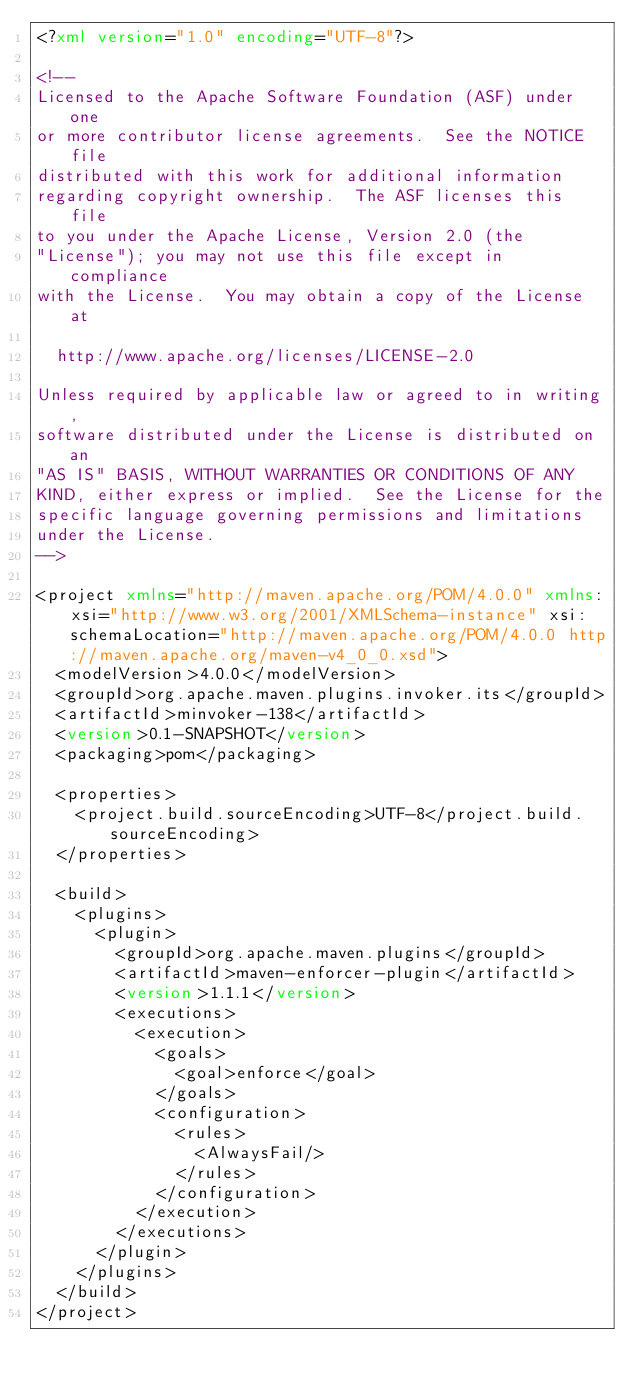<code> <loc_0><loc_0><loc_500><loc_500><_XML_><?xml version="1.0" encoding="UTF-8"?>

<!--
Licensed to the Apache Software Foundation (ASF) under one
or more contributor license agreements.  See the NOTICE file
distributed with this work for additional information
regarding copyright ownership.  The ASF licenses this file
to you under the Apache License, Version 2.0 (the
"License"); you may not use this file except in compliance
with the License.  You may obtain a copy of the License at

  http://www.apache.org/licenses/LICENSE-2.0

Unless required by applicable law or agreed to in writing,
software distributed under the License is distributed on an
"AS IS" BASIS, WITHOUT WARRANTIES OR CONDITIONS OF ANY
KIND, either express or implied.  See the License for the
specific language governing permissions and limitations
under the License.
-->

<project xmlns="http://maven.apache.org/POM/4.0.0" xmlns:xsi="http://www.w3.org/2001/XMLSchema-instance" xsi:schemaLocation="http://maven.apache.org/POM/4.0.0 http://maven.apache.org/maven-v4_0_0.xsd">
  <modelVersion>4.0.0</modelVersion>
  <groupId>org.apache.maven.plugins.invoker.its</groupId>
  <artifactId>minvoker-138</artifactId>
  <version>0.1-SNAPSHOT</version>
  <packaging>pom</packaging>

  <properties>
    <project.build.sourceEncoding>UTF-8</project.build.sourceEncoding>
  </properties>
  
  <build>
    <plugins>
      <plugin>
        <groupId>org.apache.maven.plugins</groupId>
        <artifactId>maven-enforcer-plugin</artifactId>
        <version>1.1.1</version>
        <executions>
          <execution>
            <goals>
              <goal>enforce</goal>
            </goals>
            <configuration>
              <rules>
                <AlwaysFail/>
              </rules>
            </configuration>
          </execution>
        </executions>
      </plugin>
    </plugins>
  </build>
</project>
</code> 